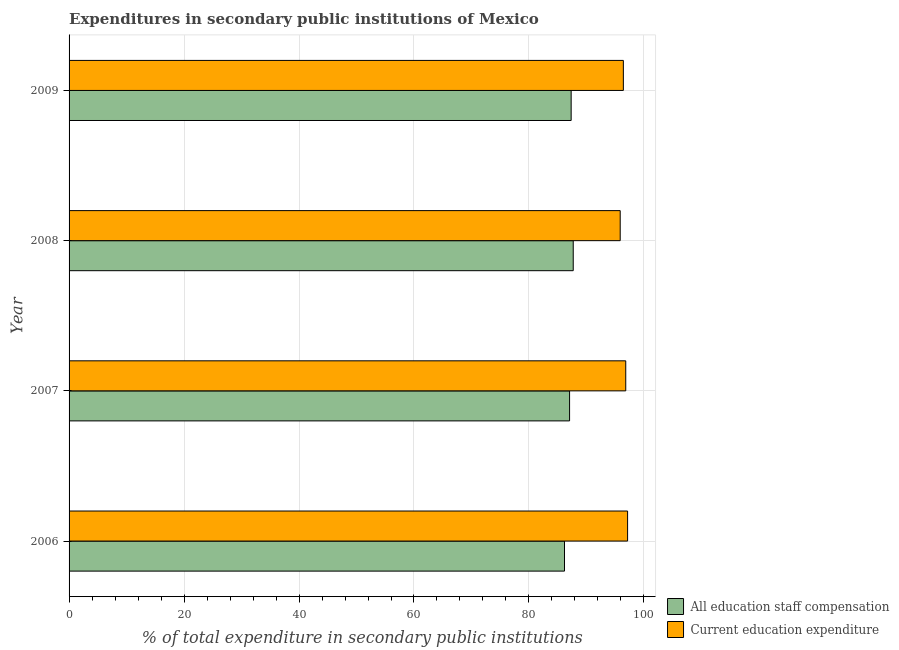How many different coloured bars are there?
Your response must be concise. 2. How many groups of bars are there?
Provide a succinct answer. 4. Are the number of bars per tick equal to the number of legend labels?
Your answer should be very brief. Yes. What is the label of the 2nd group of bars from the top?
Keep it short and to the point. 2008. In how many cases, is the number of bars for a given year not equal to the number of legend labels?
Offer a very short reply. 0. What is the expenditure in education in 2008?
Make the answer very short. 95.87. Across all years, what is the maximum expenditure in education?
Keep it short and to the point. 97.16. Across all years, what is the minimum expenditure in education?
Your answer should be very brief. 95.87. In which year was the expenditure in education maximum?
Provide a short and direct response. 2006. In which year was the expenditure in education minimum?
Your answer should be compact. 2008. What is the total expenditure in staff compensation in the graph?
Your answer should be very brief. 348.29. What is the difference between the expenditure in education in 2007 and that in 2009?
Offer a very short reply. 0.42. What is the difference between the expenditure in education in 2009 and the expenditure in staff compensation in 2007?
Make the answer very short. 9.35. What is the average expenditure in staff compensation per year?
Ensure brevity in your answer.  87.07. In the year 2007, what is the difference between the expenditure in staff compensation and expenditure in education?
Provide a succinct answer. -9.77. What is the ratio of the expenditure in staff compensation in 2006 to that in 2008?
Provide a short and direct response. 0.98. What is the difference between the highest and the second highest expenditure in staff compensation?
Ensure brevity in your answer.  0.36. What is the difference between the highest and the lowest expenditure in staff compensation?
Provide a short and direct response. 1.52. Is the sum of the expenditure in education in 2006 and 2009 greater than the maximum expenditure in staff compensation across all years?
Your response must be concise. Yes. What does the 1st bar from the top in 2008 represents?
Offer a terse response. Current education expenditure. What does the 1st bar from the bottom in 2007 represents?
Your response must be concise. All education staff compensation. What is the difference between two consecutive major ticks on the X-axis?
Ensure brevity in your answer.  20. Are the values on the major ticks of X-axis written in scientific E-notation?
Ensure brevity in your answer.  No. Where does the legend appear in the graph?
Give a very brief answer. Bottom right. How many legend labels are there?
Make the answer very short. 2. What is the title of the graph?
Your response must be concise. Expenditures in secondary public institutions of Mexico. What is the label or title of the X-axis?
Ensure brevity in your answer.  % of total expenditure in secondary public institutions. What is the % of total expenditure in secondary public institutions of All education staff compensation in 2006?
Provide a short and direct response. 86.18. What is the % of total expenditure in secondary public institutions of Current education expenditure in 2006?
Ensure brevity in your answer.  97.16. What is the % of total expenditure in secondary public institutions in All education staff compensation in 2007?
Ensure brevity in your answer.  87.07. What is the % of total expenditure in secondary public institutions in Current education expenditure in 2007?
Offer a very short reply. 96.84. What is the % of total expenditure in secondary public institutions in All education staff compensation in 2008?
Provide a short and direct response. 87.7. What is the % of total expenditure in secondary public institutions in Current education expenditure in 2008?
Your answer should be very brief. 95.87. What is the % of total expenditure in secondary public institutions of All education staff compensation in 2009?
Provide a succinct answer. 87.34. What is the % of total expenditure in secondary public institutions of Current education expenditure in 2009?
Keep it short and to the point. 96.42. Across all years, what is the maximum % of total expenditure in secondary public institutions in All education staff compensation?
Provide a short and direct response. 87.7. Across all years, what is the maximum % of total expenditure in secondary public institutions of Current education expenditure?
Offer a terse response. 97.16. Across all years, what is the minimum % of total expenditure in secondary public institutions in All education staff compensation?
Offer a terse response. 86.18. Across all years, what is the minimum % of total expenditure in secondary public institutions of Current education expenditure?
Keep it short and to the point. 95.87. What is the total % of total expenditure in secondary public institutions in All education staff compensation in the graph?
Ensure brevity in your answer.  348.29. What is the total % of total expenditure in secondary public institutions of Current education expenditure in the graph?
Keep it short and to the point. 386.28. What is the difference between the % of total expenditure in secondary public institutions in All education staff compensation in 2006 and that in 2007?
Your response must be concise. -0.88. What is the difference between the % of total expenditure in secondary public institutions in Current education expenditure in 2006 and that in 2007?
Provide a succinct answer. 0.32. What is the difference between the % of total expenditure in secondary public institutions of All education staff compensation in 2006 and that in 2008?
Provide a succinct answer. -1.52. What is the difference between the % of total expenditure in secondary public institutions of Current education expenditure in 2006 and that in 2008?
Ensure brevity in your answer.  1.29. What is the difference between the % of total expenditure in secondary public institutions in All education staff compensation in 2006 and that in 2009?
Give a very brief answer. -1.16. What is the difference between the % of total expenditure in secondary public institutions of Current education expenditure in 2006 and that in 2009?
Offer a very short reply. 0.74. What is the difference between the % of total expenditure in secondary public institutions of All education staff compensation in 2007 and that in 2008?
Provide a short and direct response. -0.63. What is the difference between the % of total expenditure in secondary public institutions of Current education expenditure in 2007 and that in 2008?
Offer a terse response. 0.96. What is the difference between the % of total expenditure in secondary public institutions of All education staff compensation in 2007 and that in 2009?
Offer a very short reply. -0.27. What is the difference between the % of total expenditure in secondary public institutions of Current education expenditure in 2007 and that in 2009?
Provide a short and direct response. 0.42. What is the difference between the % of total expenditure in secondary public institutions of All education staff compensation in 2008 and that in 2009?
Provide a succinct answer. 0.36. What is the difference between the % of total expenditure in secondary public institutions in Current education expenditure in 2008 and that in 2009?
Make the answer very short. -0.55. What is the difference between the % of total expenditure in secondary public institutions in All education staff compensation in 2006 and the % of total expenditure in secondary public institutions in Current education expenditure in 2007?
Offer a terse response. -10.65. What is the difference between the % of total expenditure in secondary public institutions in All education staff compensation in 2006 and the % of total expenditure in secondary public institutions in Current education expenditure in 2008?
Ensure brevity in your answer.  -9.69. What is the difference between the % of total expenditure in secondary public institutions of All education staff compensation in 2006 and the % of total expenditure in secondary public institutions of Current education expenditure in 2009?
Provide a short and direct response. -10.24. What is the difference between the % of total expenditure in secondary public institutions of All education staff compensation in 2007 and the % of total expenditure in secondary public institutions of Current education expenditure in 2008?
Give a very brief answer. -8.8. What is the difference between the % of total expenditure in secondary public institutions in All education staff compensation in 2007 and the % of total expenditure in secondary public institutions in Current education expenditure in 2009?
Your answer should be very brief. -9.35. What is the difference between the % of total expenditure in secondary public institutions in All education staff compensation in 2008 and the % of total expenditure in secondary public institutions in Current education expenditure in 2009?
Offer a terse response. -8.72. What is the average % of total expenditure in secondary public institutions in All education staff compensation per year?
Provide a short and direct response. 87.07. What is the average % of total expenditure in secondary public institutions of Current education expenditure per year?
Offer a terse response. 96.57. In the year 2006, what is the difference between the % of total expenditure in secondary public institutions of All education staff compensation and % of total expenditure in secondary public institutions of Current education expenditure?
Give a very brief answer. -10.98. In the year 2007, what is the difference between the % of total expenditure in secondary public institutions of All education staff compensation and % of total expenditure in secondary public institutions of Current education expenditure?
Offer a terse response. -9.77. In the year 2008, what is the difference between the % of total expenditure in secondary public institutions of All education staff compensation and % of total expenditure in secondary public institutions of Current education expenditure?
Your answer should be compact. -8.17. In the year 2009, what is the difference between the % of total expenditure in secondary public institutions of All education staff compensation and % of total expenditure in secondary public institutions of Current education expenditure?
Provide a short and direct response. -9.08. What is the ratio of the % of total expenditure in secondary public institutions of All education staff compensation in 2006 to that in 2007?
Provide a short and direct response. 0.99. What is the ratio of the % of total expenditure in secondary public institutions in Current education expenditure in 2006 to that in 2007?
Give a very brief answer. 1. What is the ratio of the % of total expenditure in secondary public institutions of All education staff compensation in 2006 to that in 2008?
Keep it short and to the point. 0.98. What is the ratio of the % of total expenditure in secondary public institutions of Current education expenditure in 2006 to that in 2008?
Offer a terse response. 1.01. What is the ratio of the % of total expenditure in secondary public institutions of Current education expenditure in 2006 to that in 2009?
Give a very brief answer. 1.01. What is the ratio of the % of total expenditure in secondary public institutions in All education staff compensation in 2007 to that in 2009?
Give a very brief answer. 1. What is the difference between the highest and the second highest % of total expenditure in secondary public institutions of All education staff compensation?
Make the answer very short. 0.36. What is the difference between the highest and the second highest % of total expenditure in secondary public institutions in Current education expenditure?
Ensure brevity in your answer.  0.32. What is the difference between the highest and the lowest % of total expenditure in secondary public institutions of All education staff compensation?
Ensure brevity in your answer.  1.52. What is the difference between the highest and the lowest % of total expenditure in secondary public institutions in Current education expenditure?
Provide a succinct answer. 1.29. 